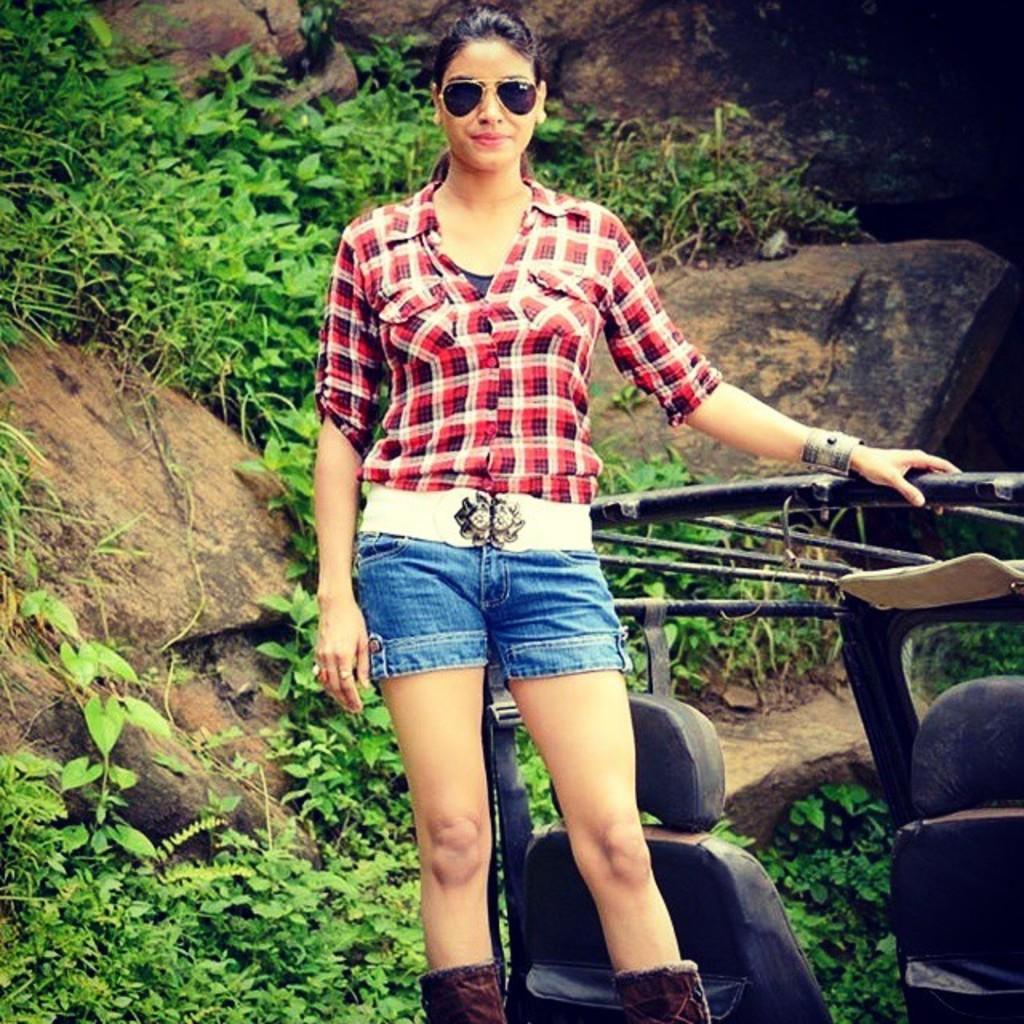Can you describe this image briefly? In this image there is a woman standing on a vehicle, she is wearing goggles, red check shirt, blue shorts and brown shoes. In the background there are some plants and rocks. 